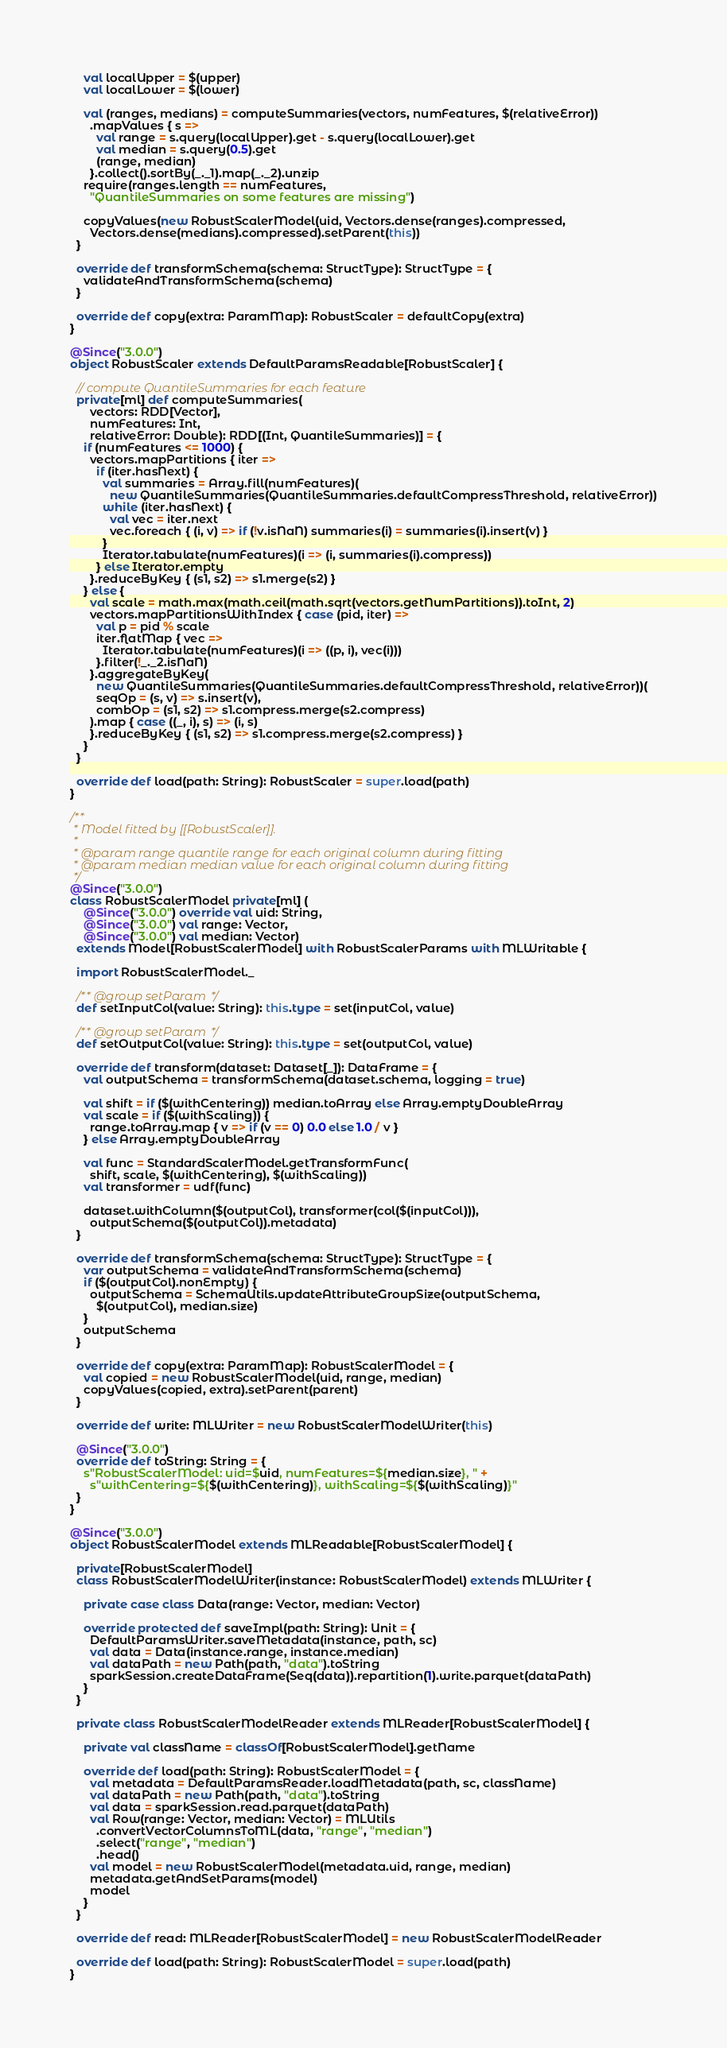Convert code to text. <code><loc_0><loc_0><loc_500><loc_500><_Scala_>    val localUpper = $(upper)
    val localLower = $(lower)

    val (ranges, medians) = computeSummaries(vectors, numFeatures, $(relativeError))
      .mapValues { s =>
        val range = s.query(localUpper).get - s.query(localLower).get
        val median = s.query(0.5).get
        (range, median)
      }.collect().sortBy(_._1).map(_._2).unzip
    require(ranges.length == numFeatures,
      "QuantileSummaries on some features are missing")

    copyValues(new RobustScalerModel(uid, Vectors.dense(ranges).compressed,
      Vectors.dense(medians).compressed).setParent(this))
  }

  override def transformSchema(schema: StructType): StructType = {
    validateAndTransformSchema(schema)
  }

  override def copy(extra: ParamMap): RobustScaler = defaultCopy(extra)
}

@Since("3.0.0")
object RobustScaler extends DefaultParamsReadable[RobustScaler] {

  // compute QuantileSummaries for each feature
  private[ml] def computeSummaries(
      vectors: RDD[Vector],
      numFeatures: Int,
      relativeError: Double): RDD[(Int, QuantileSummaries)] = {
    if (numFeatures <= 1000) {
      vectors.mapPartitions { iter =>
        if (iter.hasNext) {
          val summaries = Array.fill(numFeatures)(
            new QuantileSummaries(QuantileSummaries.defaultCompressThreshold, relativeError))
          while (iter.hasNext) {
            val vec = iter.next
            vec.foreach { (i, v) => if (!v.isNaN) summaries(i) = summaries(i).insert(v) }
          }
          Iterator.tabulate(numFeatures)(i => (i, summaries(i).compress))
        } else Iterator.empty
      }.reduceByKey { (s1, s2) => s1.merge(s2) }
    } else {
      val scale = math.max(math.ceil(math.sqrt(vectors.getNumPartitions)).toInt, 2)
      vectors.mapPartitionsWithIndex { case (pid, iter) =>
        val p = pid % scale
        iter.flatMap { vec =>
          Iterator.tabulate(numFeatures)(i => ((p, i), vec(i)))
        }.filter(!_._2.isNaN)
      }.aggregateByKey(
        new QuantileSummaries(QuantileSummaries.defaultCompressThreshold, relativeError))(
        seqOp = (s, v) => s.insert(v),
        combOp = (s1, s2) => s1.compress.merge(s2.compress)
      ).map { case ((_, i), s) => (i, s)
      }.reduceByKey { (s1, s2) => s1.compress.merge(s2.compress) }
    }
  }

  override def load(path: String): RobustScaler = super.load(path)
}

/**
 * Model fitted by [[RobustScaler]].
 *
 * @param range quantile range for each original column during fitting
 * @param median median value for each original column during fitting
 */
@Since("3.0.0")
class RobustScalerModel private[ml] (
    @Since("3.0.0") override val uid: String,
    @Since("3.0.0") val range: Vector,
    @Since("3.0.0") val median: Vector)
  extends Model[RobustScalerModel] with RobustScalerParams with MLWritable {

  import RobustScalerModel._

  /** @group setParam */
  def setInputCol(value: String): this.type = set(inputCol, value)

  /** @group setParam */
  def setOutputCol(value: String): this.type = set(outputCol, value)

  override def transform(dataset: Dataset[_]): DataFrame = {
    val outputSchema = transformSchema(dataset.schema, logging = true)

    val shift = if ($(withCentering)) median.toArray else Array.emptyDoubleArray
    val scale = if ($(withScaling)) {
      range.toArray.map { v => if (v == 0) 0.0 else 1.0 / v }
    } else Array.emptyDoubleArray

    val func = StandardScalerModel.getTransformFunc(
      shift, scale, $(withCentering), $(withScaling))
    val transformer = udf(func)

    dataset.withColumn($(outputCol), transformer(col($(inputCol))),
      outputSchema($(outputCol)).metadata)
  }

  override def transformSchema(schema: StructType): StructType = {
    var outputSchema = validateAndTransformSchema(schema)
    if ($(outputCol).nonEmpty) {
      outputSchema = SchemaUtils.updateAttributeGroupSize(outputSchema,
        $(outputCol), median.size)
    }
    outputSchema
  }

  override def copy(extra: ParamMap): RobustScalerModel = {
    val copied = new RobustScalerModel(uid, range, median)
    copyValues(copied, extra).setParent(parent)
  }

  override def write: MLWriter = new RobustScalerModelWriter(this)

  @Since("3.0.0")
  override def toString: String = {
    s"RobustScalerModel: uid=$uid, numFeatures=${median.size}, " +
      s"withCentering=${$(withCentering)}, withScaling=${$(withScaling)}"
  }
}

@Since("3.0.0")
object RobustScalerModel extends MLReadable[RobustScalerModel] {

  private[RobustScalerModel]
  class RobustScalerModelWriter(instance: RobustScalerModel) extends MLWriter {

    private case class Data(range: Vector, median: Vector)

    override protected def saveImpl(path: String): Unit = {
      DefaultParamsWriter.saveMetadata(instance, path, sc)
      val data = Data(instance.range, instance.median)
      val dataPath = new Path(path, "data").toString
      sparkSession.createDataFrame(Seq(data)).repartition(1).write.parquet(dataPath)
    }
  }

  private class RobustScalerModelReader extends MLReader[RobustScalerModel] {

    private val className = classOf[RobustScalerModel].getName

    override def load(path: String): RobustScalerModel = {
      val metadata = DefaultParamsReader.loadMetadata(path, sc, className)
      val dataPath = new Path(path, "data").toString
      val data = sparkSession.read.parquet(dataPath)
      val Row(range: Vector, median: Vector) = MLUtils
        .convertVectorColumnsToML(data, "range", "median")
        .select("range", "median")
        .head()
      val model = new RobustScalerModel(metadata.uid, range, median)
      metadata.getAndSetParams(model)
      model
    }
  }

  override def read: MLReader[RobustScalerModel] = new RobustScalerModelReader

  override def load(path: String): RobustScalerModel = super.load(path)
}
</code> 